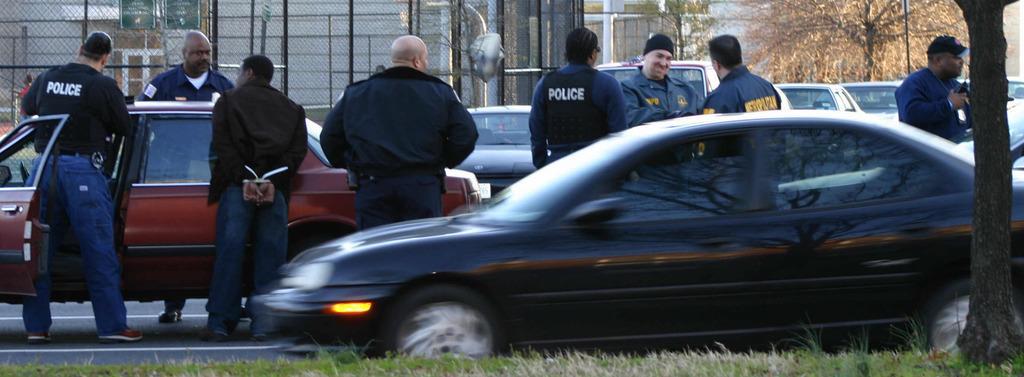How would you summarize this image in a sentence or two? In this image there are vehicle on a road and people are standing, in the background there are trees and fencing. 